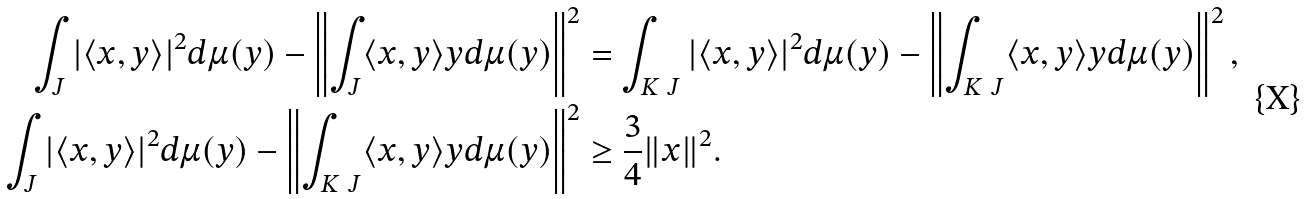Convert formula to latex. <formula><loc_0><loc_0><loc_500><loc_500>\int _ { J } | \langle x , y \rangle | ^ { 2 } d \mu ( y ) - \left \| \int _ { J } \langle x , y \rangle y d \mu ( y ) \right \| ^ { 2 } & = \int _ { K \ J } | \langle x , y \rangle | ^ { 2 } d \mu ( y ) - \left \| \int _ { K \ J } \langle x , y \rangle y d \mu ( y ) \right \| ^ { 2 } , \\ \int _ { J } | \langle x , y \rangle | ^ { 2 } d \mu ( y ) - \left \| \int _ { K \ J } \langle x , y \rangle y d \mu ( y ) \right \| ^ { 2 } & \geq \frac { 3 } { 4 } \| x \| ^ { 2 } .</formula> 